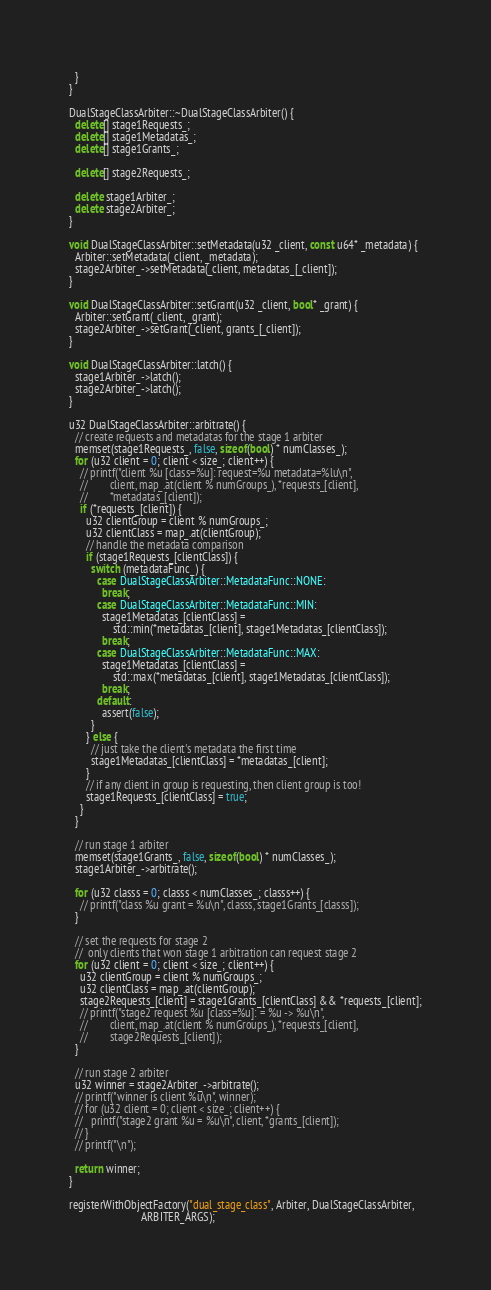Convert code to text. <code><loc_0><loc_0><loc_500><loc_500><_C++_>  }
}

DualStageClassArbiter::~DualStageClassArbiter() {
  delete[] stage1Requests_;
  delete[] stage1Metadatas_;
  delete[] stage1Grants_;

  delete[] stage2Requests_;

  delete stage1Arbiter_;
  delete stage2Arbiter_;
}

void DualStageClassArbiter::setMetadata(u32 _client, const u64* _metadata) {
  Arbiter::setMetadata(_client, _metadata);
  stage2Arbiter_->setMetadata(_client, metadatas_[_client]);
}

void DualStageClassArbiter::setGrant(u32 _client, bool* _grant) {
  Arbiter::setGrant(_client, _grant);
  stage2Arbiter_->setGrant(_client, grants_[_client]);
}

void DualStageClassArbiter::latch() {
  stage1Arbiter_->latch();
  stage2Arbiter_->latch();
}

u32 DualStageClassArbiter::arbitrate() {
  // create requests and metadatas for the stage 1 arbiter
  memset(stage1Requests_, false, sizeof(bool) * numClasses_);
  for (u32 client = 0; client < size_; client++) {
    // printf("client %u [class=%u]: request=%u metadata=%lu\n",
    //        client, map_.at(client % numGroups_), *requests_[client],
    //        *metadatas_[client]);
    if (*requests_[client]) {
      u32 clientGroup = client % numGroups_;
      u32 clientClass = map_.at(clientGroup);
      // handle the metadata comparison
      if (stage1Requests_[clientClass]) {
        switch (metadataFunc_) {
          case DualStageClassArbiter::MetadataFunc::NONE:
            break;
          case DualStageClassArbiter::MetadataFunc::MIN:
            stage1Metadatas_[clientClass] =
                std::min(*metadatas_[client], stage1Metadatas_[clientClass]);
            break;
          case DualStageClassArbiter::MetadataFunc::MAX:
            stage1Metadatas_[clientClass] =
                std::max(*metadatas_[client], stage1Metadatas_[clientClass]);
            break;
          default:
            assert(false);
        }
      } else {
        // just take the client's metadata the first time
        stage1Metadatas_[clientClass] = *metadatas_[client];
      }
      // if any client in group is requesting, then client group is too!
      stage1Requests_[clientClass] = true;
    }
  }

  // run stage 1 arbiter
  memset(stage1Grants_, false, sizeof(bool) * numClasses_);
  stage1Arbiter_->arbitrate();

  for (u32 classs = 0; classs < numClasses_; classs++) {
    // printf("class %u grant = %u\n", classs, stage1Grants_[classs]);
  }

  // set the requests for stage 2
  //  only clients that won stage 1 arbitration can request stage 2
  for (u32 client = 0; client < size_; client++) {
    u32 clientGroup = client % numGroups_;
    u32 clientClass = map_.at(clientGroup);
    stage2Requests_[client] = stage1Grants_[clientClass] && *requests_[client];
    // printf("stage2 request %u [class=%u]: = %u -> %u\n",
    //        client, map_.at(client % numGroups_), *requests_[client],
    //        stage2Requests_[client]);
  }

  // run stage 2 arbiter
  u32 winner = stage2Arbiter_->arbitrate();
  // printf("winner is client %u\n", winner);
  // for (u32 client = 0; client < size_; client++) {
  //   printf("stage2 grant %u = %u\n", client, *grants_[client]);
  // }
  // printf("\n");

  return winner;
}

registerWithObjectFactory("dual_stage_class", Arbiter, DualStageClassArbiter,
                          ARBITER_ARGS);
</code> 